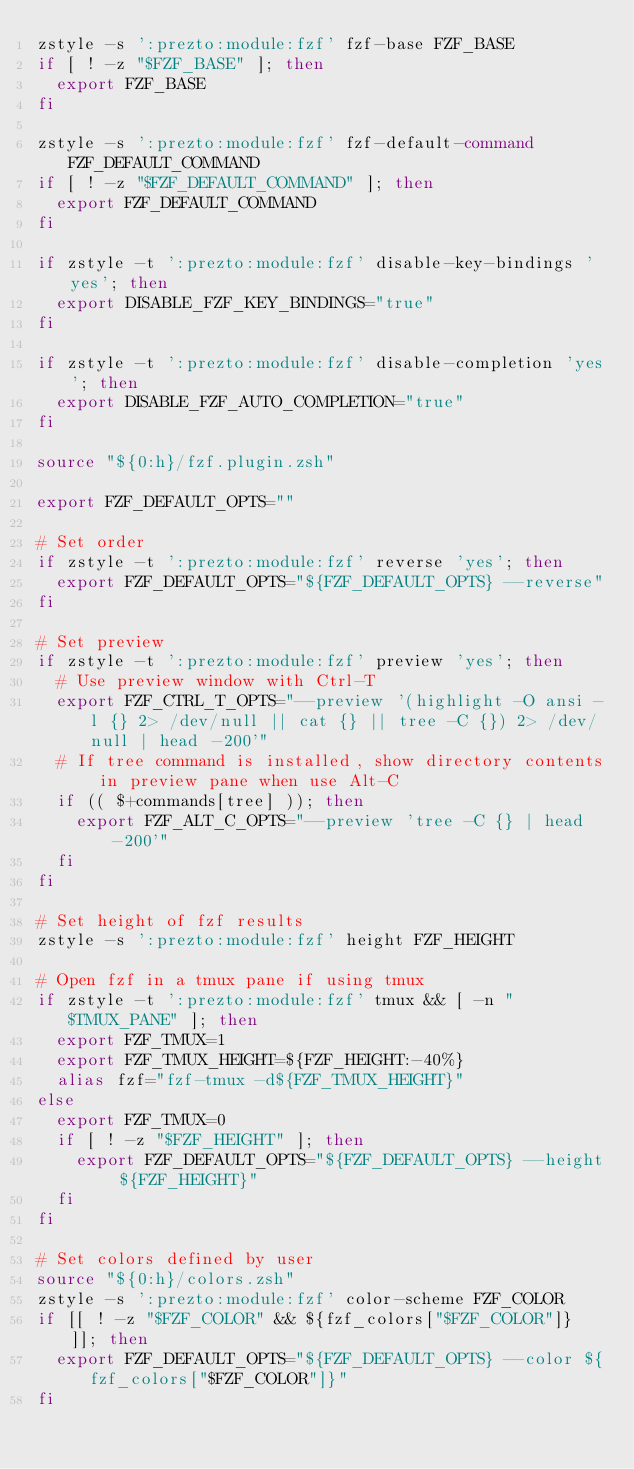Convert code to text. <code><loc_0><loc_0><loc_500><loc_500><_Bash_>zstyle -s ':prezto:module:fzf' fzf-base FZF_BASE
if [ ! -z "$FZF_BASE" ]; then
  export FZF_BASE
fi

zstyle -s ':prezto:module:fzf' fzf-default-command FZF_DEFAULT_COMMAND
if [ ! -z "$FZF_DEFAULT_COMMAND" ]; then
  export FZF_DEFAULT_COMMAND
fi

if zstyle -t ':prezto:module:fzf' disable-key-bindings 'yes'; then
  export DISABLE_FZF_KEY_BINDINGS="true"
fi

if zstyle -t ':prezto:module:fzf' disable-completion 'yes'; then
  export DISABLE_FZF_AUTO_COMPLETION="true"
fi

source "${0:h}/fzf.plugin.zsh"

export FZF_DEFAULT_OPTS=""

# Set order
if zstyle -t ':prezto:module:fzf' reverse 'yes'; then
  export FZF_DEFAULT_OPTS="${FZF_DEFAULT_OPTS} --reverse"
fi

# Set preview
if zstyle -t ':prezto:module:fzf' preview 'yes'; then
  # Use preview window with Ctrl-T
  export FZF_CTRL_T_OPTS="--preview '(highlight -O ansi -l {} 2> /dev/null || cat {} || tree -C {}) 2> /dev/null | head -200'"
  # If tree command is installed, show directory contents in preview pane when use Alt-C
  if (( $+commands[tree] )); then
	  export FZF_ALT_C_OPTS="--preview 'tree -C {} | head -200'"
  fi
fi

# Set height of fzf results
zstyle -s ':prezto:module:fzf' height FZF_HEIGHT

# Open fzf in a tmux pane if using tmux
if zstyle -t ':prezto:module:fzf' tmux && [ -n "$TMUX_PANE" ]; then
  export FZF_TMUX=1
  export FZF_TMUX_HEIGHT=${FZF_HEIGHT:-40%}
  alias fzf="fzf-tmux -d${FZF_TMUX_HEIGHT}"
else
  export FZF_TMUX=0
  if [ ! -z "$FZF_HEIGHT" ]; then
    export FZF_DEFAULT_OPTS="${FZF_DEFAULT_OPTS} --height ${FZF_HEIGHT}"
  fi
fi

# Set colors defined by user
source "${0:h}/colors.zsh"
zstyle -s ':prezto:module:fzf' color-scheme FZF_COLOR
if [[ ! -z "$FZF_COLOR" && ${fzf_colors["$FZF_COLOR"]} ]]; then
  export FZF_DEFAULT_OPTS="${FZF_DEFAULT_OPTS} --color ${fzf_colors["$FZF_COLOR"]}"
fi


</code> 